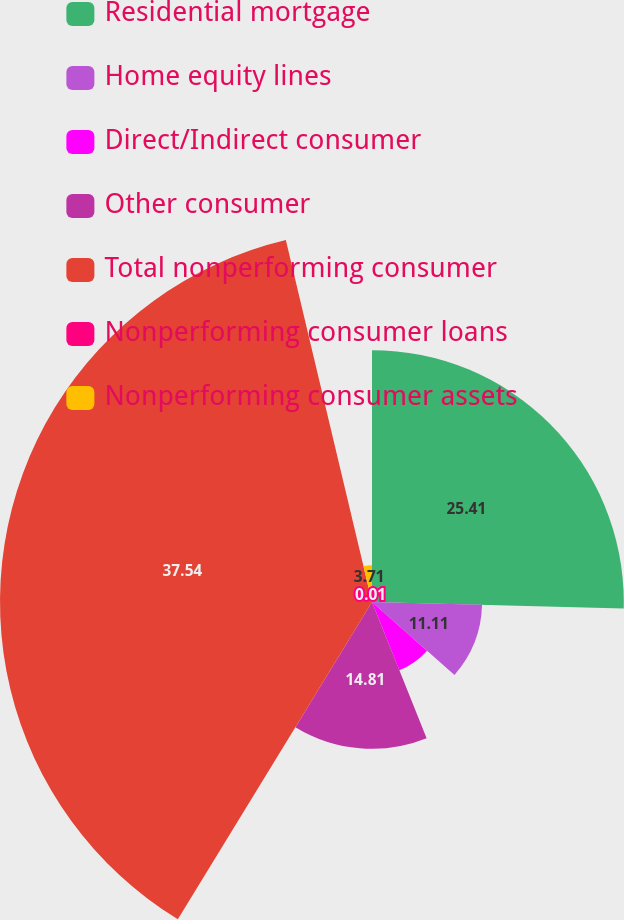Convert chart to OTSL. <chart><loc_0><loc_0><loc_500><loc_500><pie_chart><fcel>Residential mortgage<fcel>Home equity lines<fcel>Direct/Indirect consumer<fcel>Other consumer<fcel>Total nonperforming consumer<fcel>Nonperforming consumer loans<fcel>Nonperforming consumer assets<nl><fcel>25.41%<fcel>11.11%<fcel>7.41%<fcel>14.81%<fcel>37.54%<fcel>0.01%<fcel>3.71%<nl></chart> 